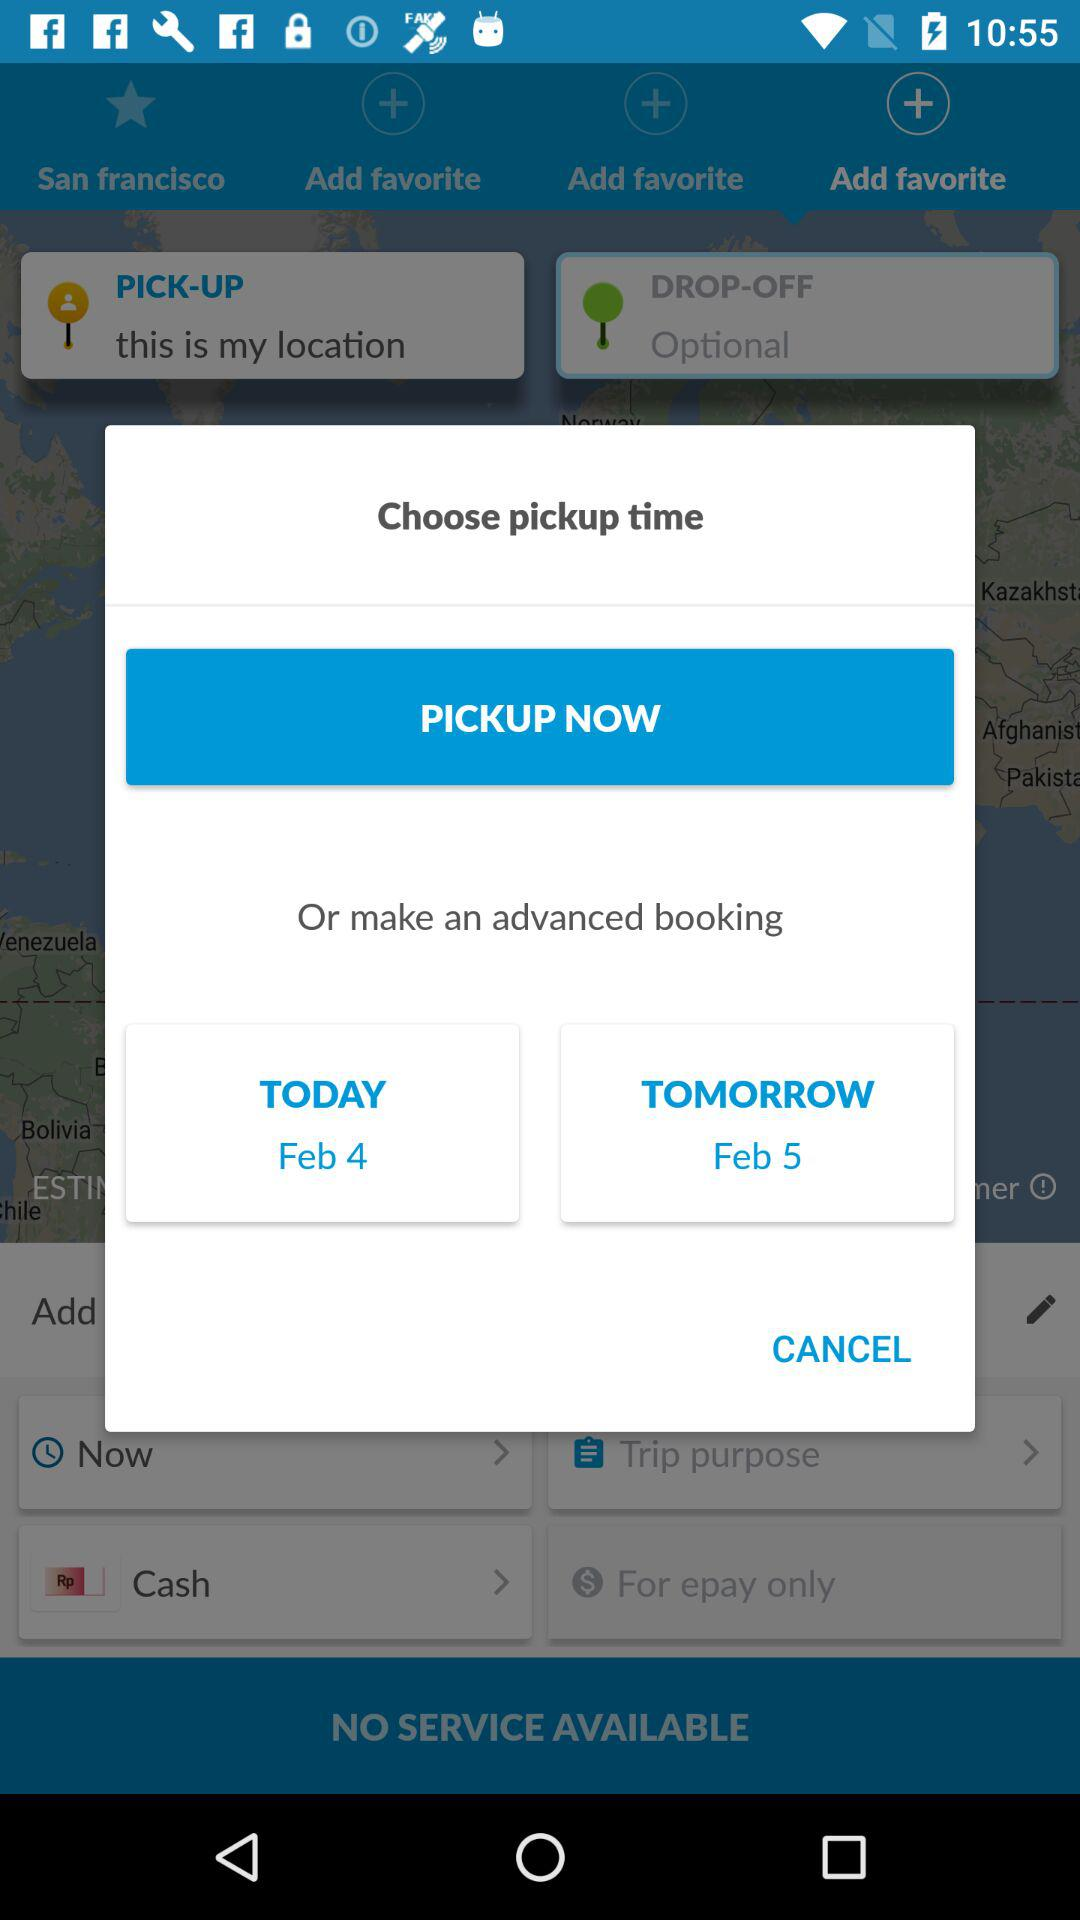How many days are available for pickup?
Answer the question using a single word or phrase. 2 